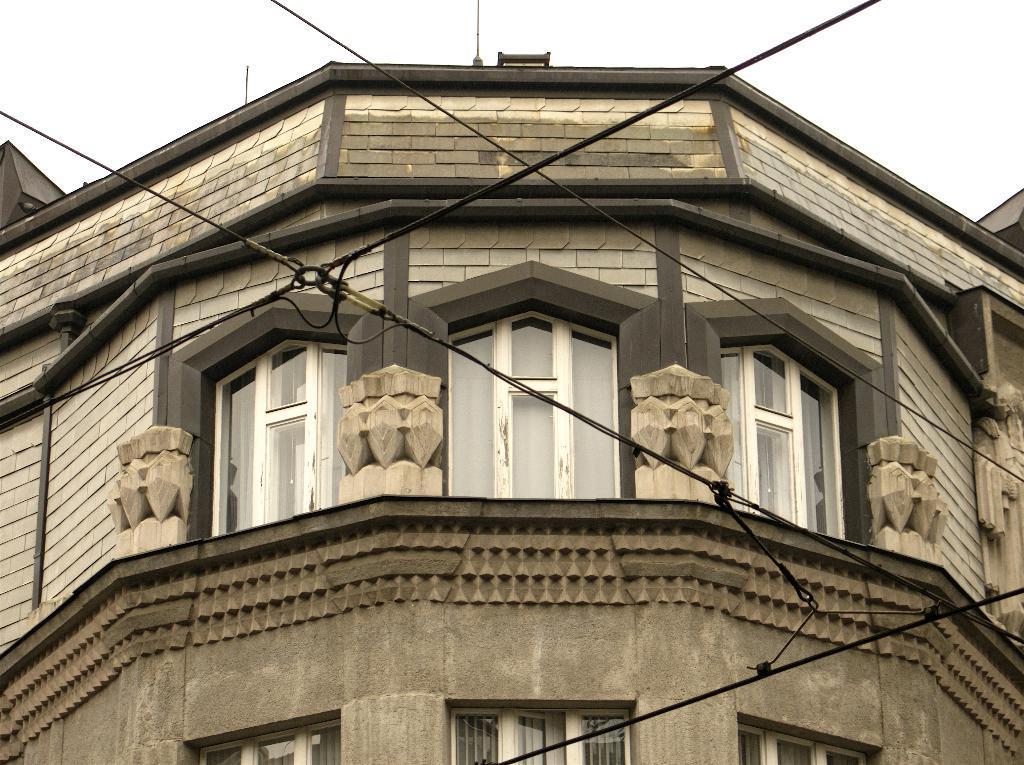Could you give a brief overview of what you see in this image? In the center of the image there is a building. In the background we can see sky. 